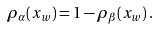Convert formula to latex. <formula><loc_0><loc_0><loc_500><loc_500>\rho _ { \alpha } ( x _ { w } ) = 1 - \rho _ { \beta } ( x _ { w } ) \, .</formula> 